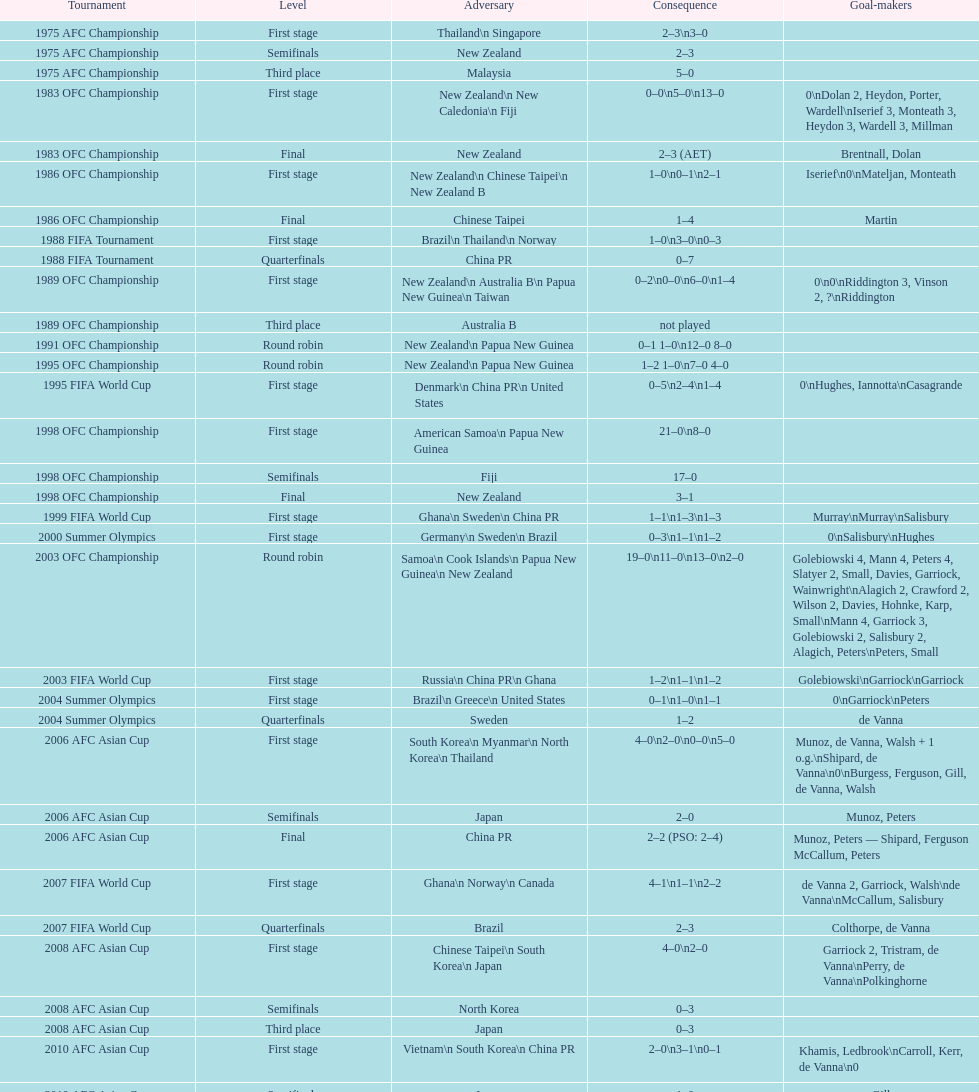Who scored better in the 1995 fifa world cup denmark or the united states? United States. 